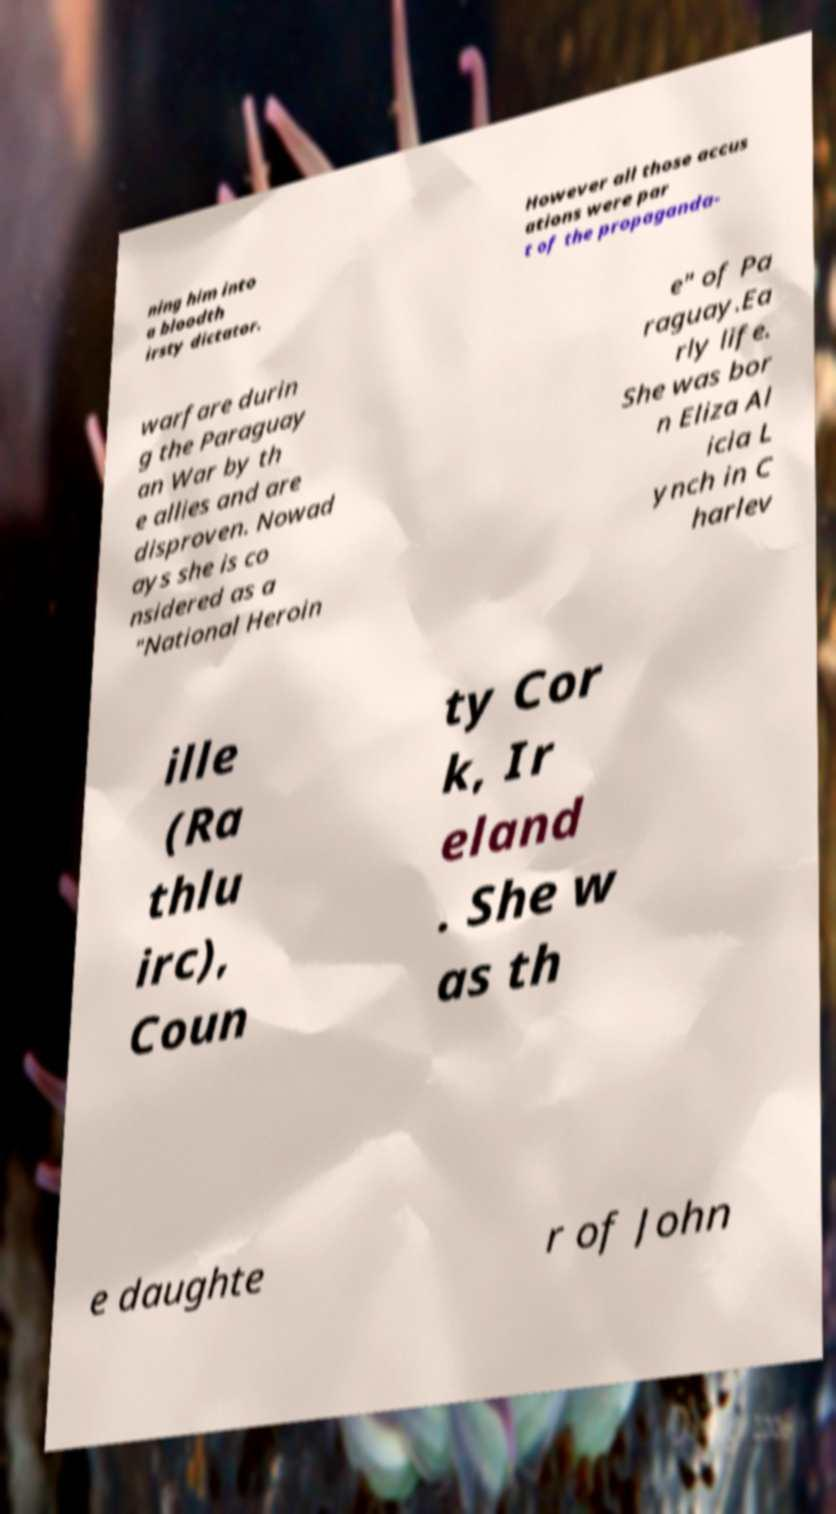Please read and relay the text visible in this image. What does it say? ning him into a bloodth irsty dictator. However all those accus ations were par t of the propaganda- warfare durin g the Paraguay an War by th e allies and are disproven. Nowad ays she is co nsidered as a "National Heroin e" of Pa raguay.Ea rly life. She was bor n Eliza Al icia L ynch in C harlev ille (Ra thlu irc), Coun ty Cor k, Ir eland . She w as th e daughte r of John 